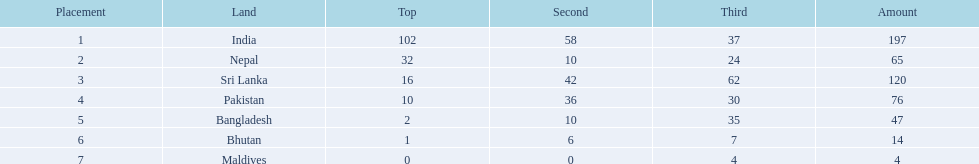What nations took part in 1999 south asian games? India, Nepal, Sri Lanka, Pakistan, Bangladesh, Bhutan, Maldives. Would you mind parsing the complete table? {'header': ['Placement', 'Land', 'Top', 'Second', 'Third', 'Amount'], 'rows': [['1', 'India', '102', '58', '37', '197'], ['2', 'Nepal', '32', '10', '24', '65'], ['3', 'Sri Lanka', '16', '42', '62', '120'], ['4', 'Pakistan', '10', '36', '30', '76'], ['5', 'Bangladesh', '2', '10', '35', '47'], ['6', 'Bhutan', '1', '6', '7', '14'], ['7', 'Maldives', '0', '0', '4', '4']]} Of those who earned gold medals? India, Nepal, Sri Lanka, Pakistan, Bangladesh, Bhutan. Which nation didn't earn any gold medals? Maldives. 